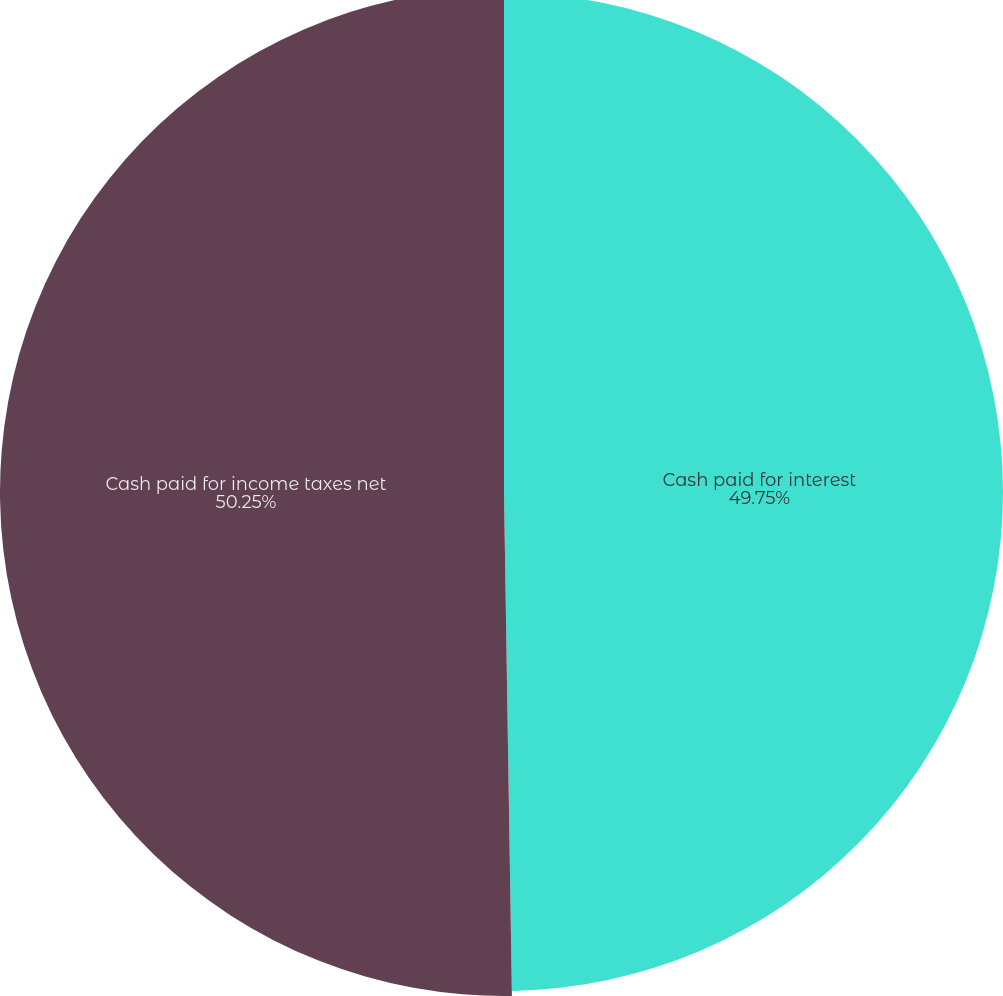Convert chart. <chart><loc_0><loc_0><loc_500><loc_500><pie_chart><fcel>Cash paid for interest<fcel>Cash paid for income taxes net<nl><fcel>49.75%<fcel>50.25%<nl></chart> 